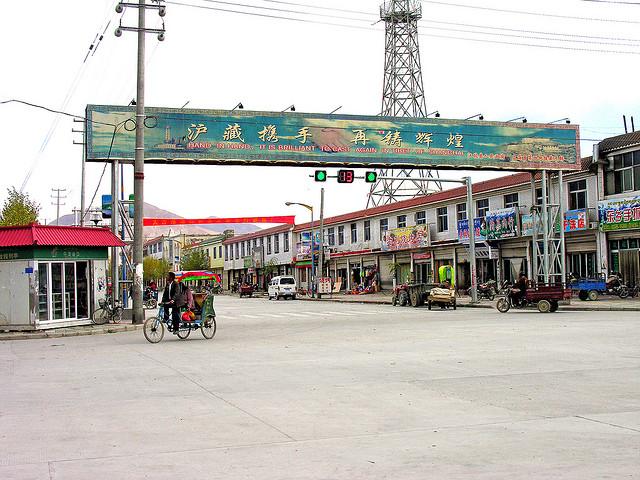How many rickshaws are there?
Give a very brief answer. 1. Is this an English speaking country?
Short answer required. No. How is the passenger's cart  to the left called?
Keep it brief. Rickshaw. What country is this?
Short answer required. Japan. 